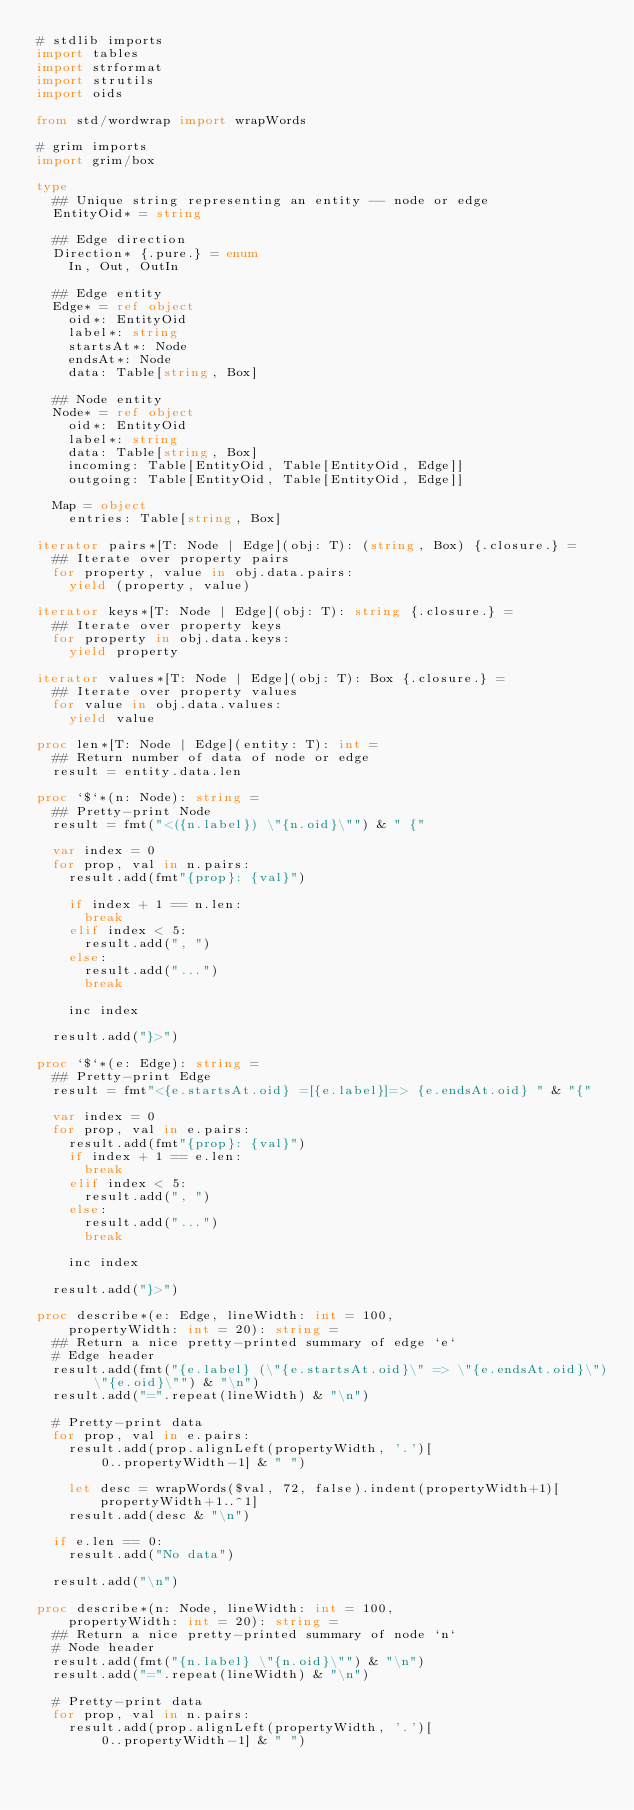Convert code to text. <code><loc_0><loc_0><loc_500><loc_500><_Nim_># stdlib imports
import tables
import strformat
import strutils
import oids

from std/wordwrap import wrapWords

# grim imports
import grim/box

type
  ## Unique string representing an entity -- node or edge
  EntityOid* = string

  ## Edge direction
  Direction* {.pure.} = enum
    In, Out, OutIn

  ## Edge entity
  Edge* = ref object
    oid*: EntityOid
    label*: string
    startsAt*: Node
    endsAt*: Node
    data: Table[string, Box]

  ## Node entity
  Node* = ref object
    oid*: EntityOid
    label*: string
    data: Table[string, Box]
    incoming: Table[EntityOid, Table[EntityOid, Edge]]
    outgoing: Table[EntityOid, Table[EntityOid, Edge]]

  Map = object
    entries: Table[string, Box]

iterator pairs*[T: Node | Edge](obj: T): (string, Box) {.closure.} =
  ## Iterate over property pairs
  for property, value in obj.data.pairs:
    yield (property, value)

iterator keys*[T: Node | Edge](obj: T): string {.closure.} =
  ## Iterate over property keys
  for property in obj.data.keys:
    yield property

iterator values*[T: Node | Edge](obj: T): Box {.closure.} =
  ## Iterate over property values
  for value in obj.data.values:
    yield value

proc len*[T: Node | Edge](entity: T): int =
  ## Return number of data of node or edge
  result = entity.data.len

proc `$`*(n: Node): string =
  ## Pretty-print Node
  result = fmt("<({n.label}) \"{n.oid}\"") & " {"

  var index = 0
  for prop, val in n.pairs: 
    result.add(fmt"{prop}: {val}")

    if index + 1 == n.len:
      break
    elif index < 5:
      result.add(", ")
    else:
      result.add("...")
      break

    inc index

  result.add("}>")

proc `$`*(e: Edge): string =
  ## Pretty-print Edge
  result = fmt"<{e.startsAt.oid} =[{e.label}]=> {e.endsAt.oid} " & "{"

  var index = 0
  for prop, val in e.pairs:
    result.add(fmt"{prop}: {val}")
    if index + 1 == e.len:
      break
    elif index < 5:
      result.add(", ")
    else:
      result.add("...")
      break

    inc index

  result.add("}>")

proc describe*(e: Edge, lineWidth: int = 100,
    propertyWidth: int = 20): string =
  ## Return a nice pretty-printed summary of edge `e`
  # Edge header
  result.add(fmt("{e.label} (\"{e.startsAt.oid}\" => \"{e.endsAt.oid}\") \"{e.oid}\"") & "\n")
  result.add("=".repeat(lineWidth) & "\n")

  # Pretty-print data
  for prop, val in e.pairs:
    result.add(prop.alignLeft(propertyWidth, '.')[
        0..propertyWidth-1] & " ")

    let desc = wrapWords($val, 72, false).indent(propertyWidth+1)[
        propertyWidth+1..^1]
    result.add(desc & "\n")

  if e.len == 0:
    result.add("No data")

  result.add("\n")

proc describe*(n: Node, lineWidth: int = 100,
    propertyWidth: int = 20): string =
  ## Return a nice pretty-printed summary of node `n`
  # Node header
  result.add(fmt("{n.label} \"{n.oid}\"") & "\n")
  result.add("=".repeat(lineWidth) & "\n")

  # Pretty-print data
  for prop, val in n.pairs:
    result.add(prop.alignLeft(propertyWidth, '.')[
        0..propertyWidth-1] & " ")
</code> 